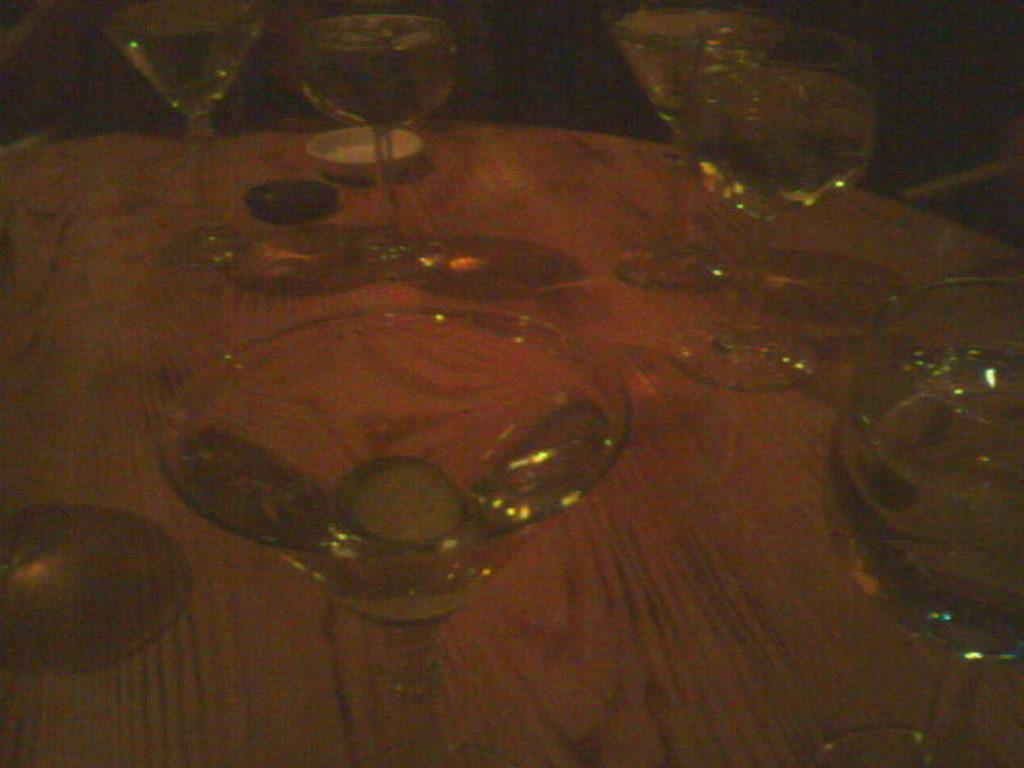Describe this image in one or two sentences. In this image we can see glasses and some objects on the wooden surface. 